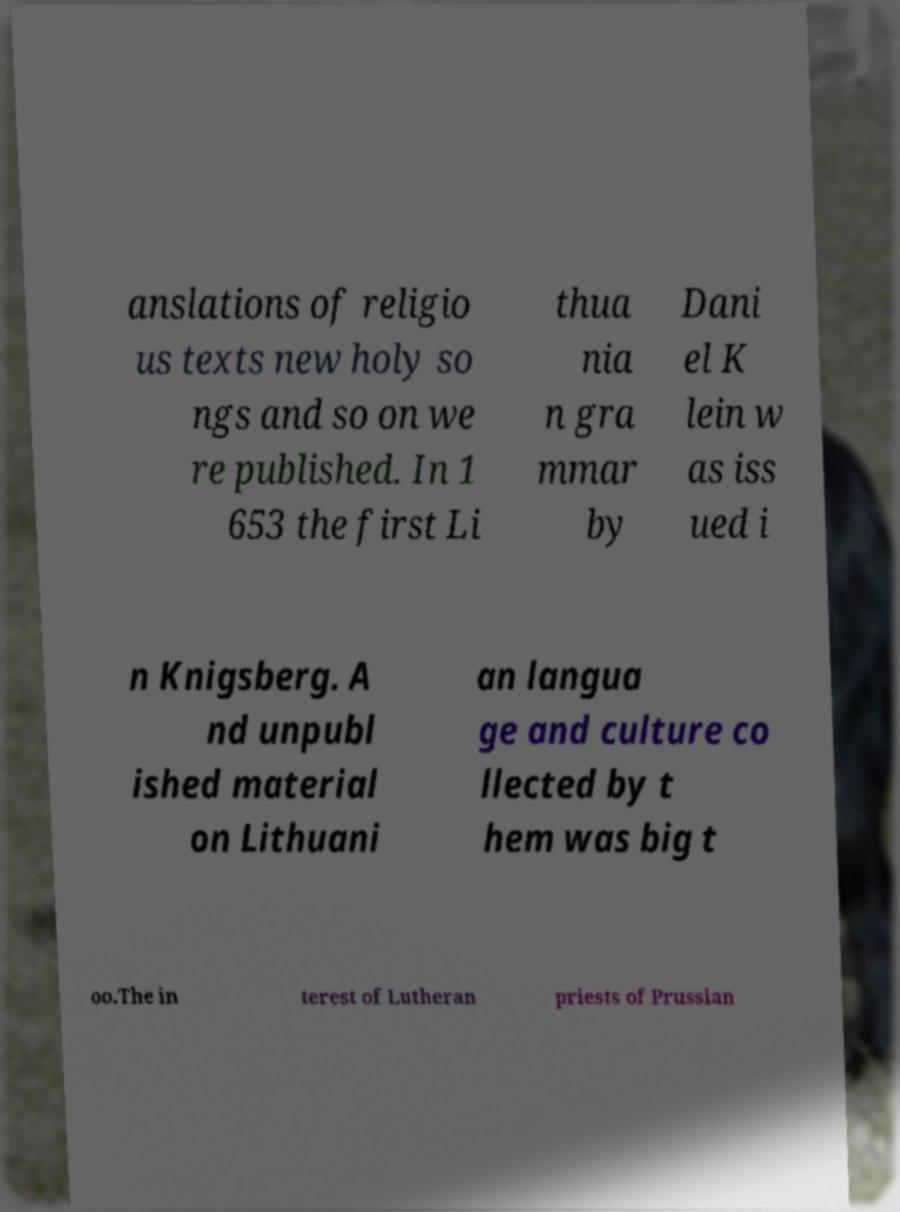I need the written content from this picture converted into text. Can you do that? anslations of religio us texts new holy so ngs and so on we re published. In 1 653 the first Li thua nia n gra mmar by Dani el K lein w as iss ued i n Knigsberg. A nd unpubl ished material on Lithuani an langua ge and culture co llected by t hem was big t oo.The in terest of Lutheran priests of Prussian 